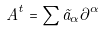<formula> <loc_0><loc_0><loc_500><loc_500>A ^ { t } = \sum \tilde { a } _ { \alpha } \partial ^ { \alpha }</formula> 